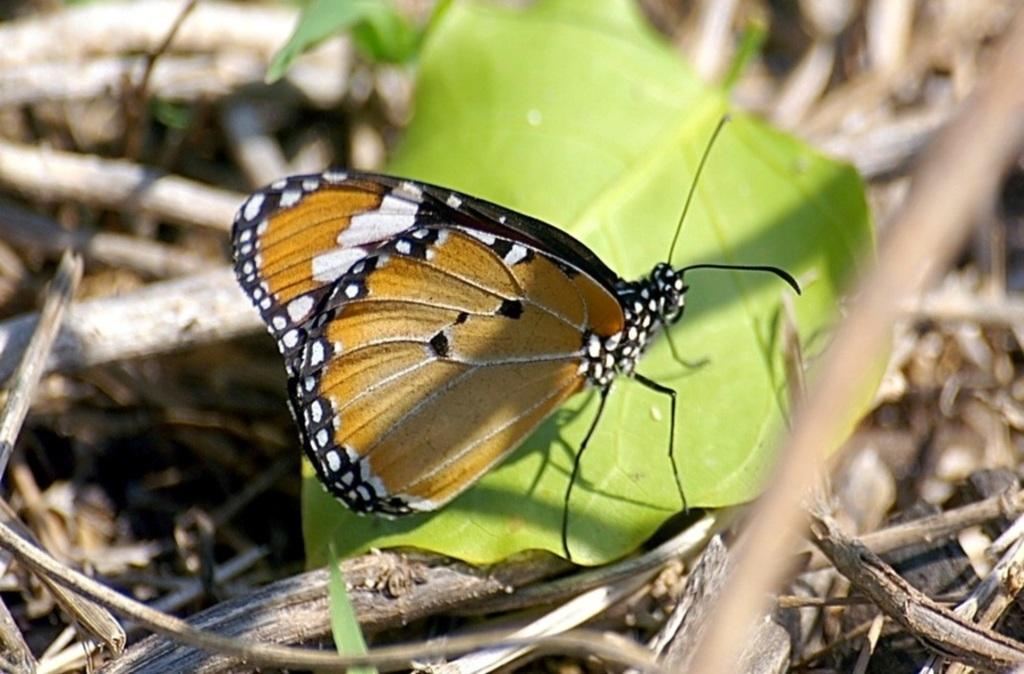What is the main subject of the picture? The main subject of the picture is a butterfly. Where is the butterfly located in the image? The butterfly is on a leaf in the image. What is the position of the leaf in the image? The leaf is in the center of the image. What colors can be seen on the butterfly? The butterfly has brown, white, and black colors. What can be seen in the background of the image? There are dried plants in the background of the image. What grade does the bell receive in the image? There is no bell present in the image, so it is not possible to determine a grade for it. 